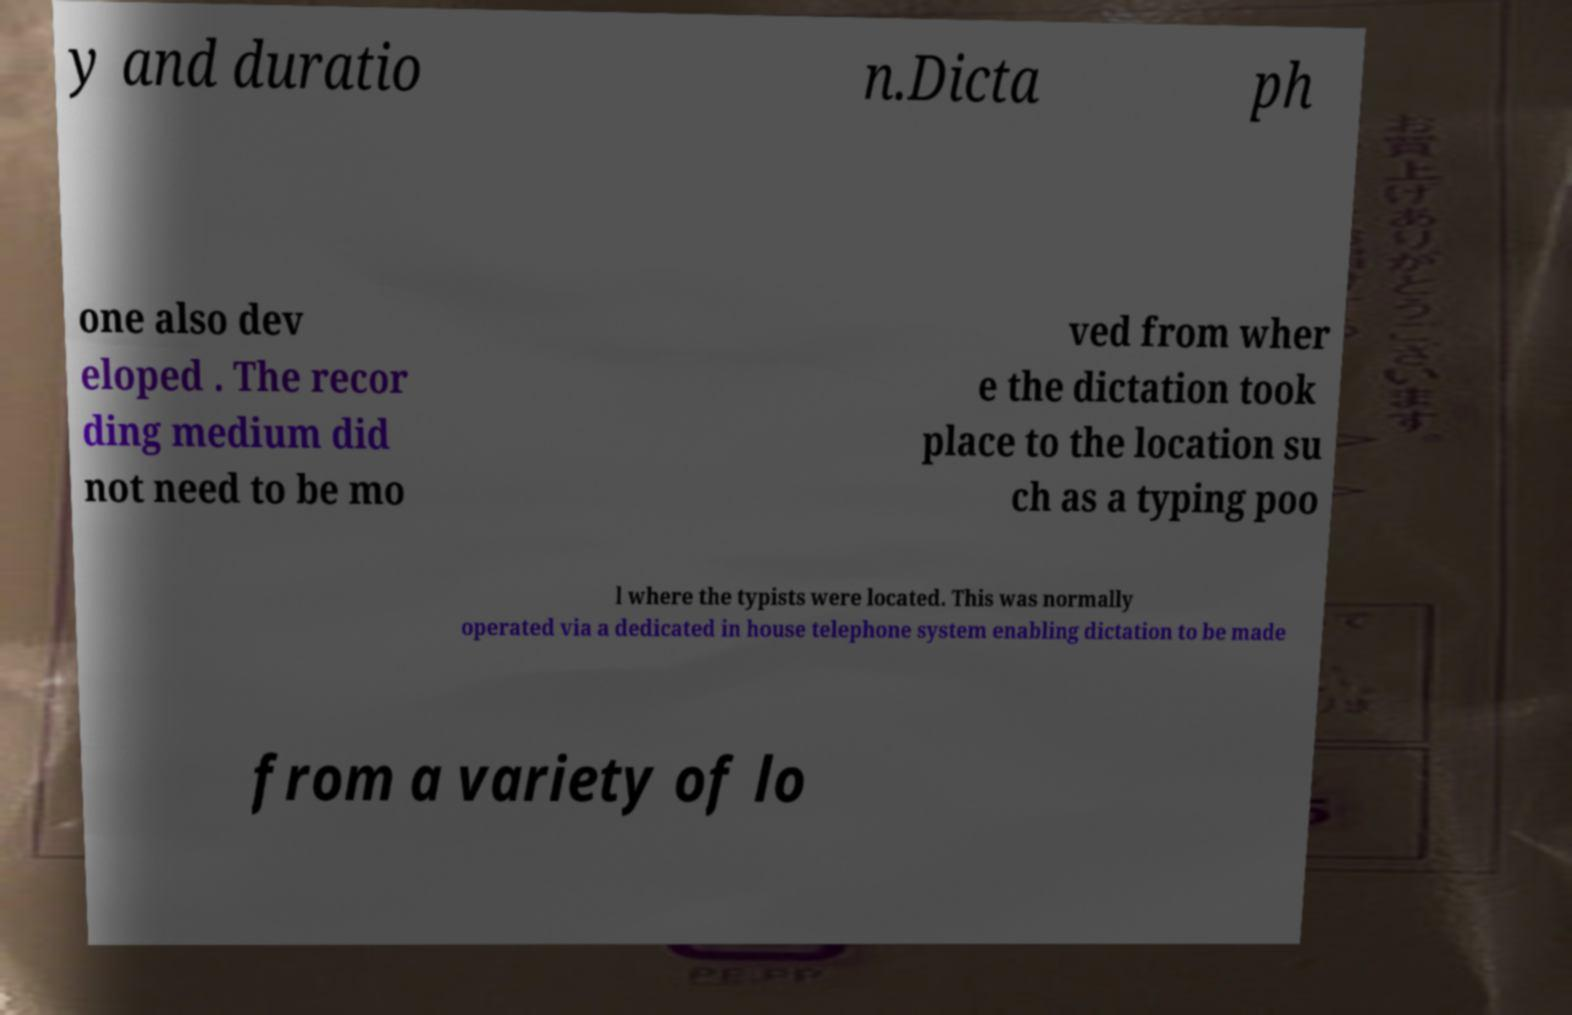There's text embedded in this image that I need extracted. Can you transcribe it verbatim? y and duratio n.Dicta ph one also dev eloped . The recor ding medium did not need to be mo ved from wher e the dictation took place to the location su ch as a typing poo l where the typists were located. This was normally operated via a dedicated in house telephone system enabling dictation to be made from a variety of lo 